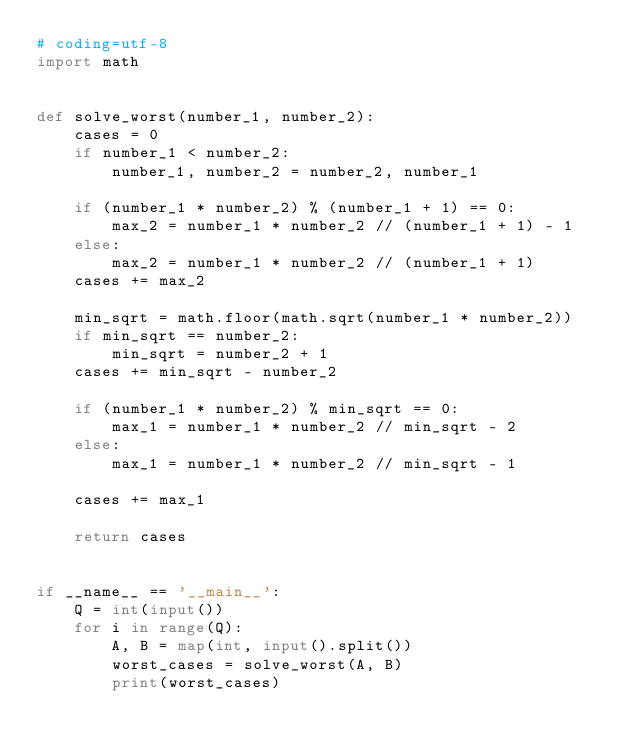<code> <loc_0><loc_0><loc_500><loc_500><_Python_># coding=utf-8
import math


def solve_worst(number_1, number_2):
    cases = 0
    if number_1 < number_2:
        number_1, number_2 = number_2, number_1

    if (number_1 * number_2) % (number_1 + 1) == 0:
        max_2 = number_1 * number_2 // (number_1 + 1) - 1
    else:
        max_2 = number_1 * number_2 // (number_1 + 1)
    cases += max_2

    min_sqrt = math.floor(math.sqrt(number_1 * number_2))
    if min_sqrt == number_2:
        min_sqrt = number_2 + 1
    cases += min_sqrt - number_2

    if (number_1 * number_2) % min_sqrt == 0:
        max_1 = number_1 * number_2 // min_sqrt - 2
    else:
        max_1 = number_1 * number_2 // min_sqrt - 1

    cases += max_1

    return cases


if __name__ == '__main__':
    Q = int(input())
    for i in range(Q):
        A, B = map(int, input().split())
        worst_cases = solve_worst(A, B)
        print(worst_cases)
</code> 